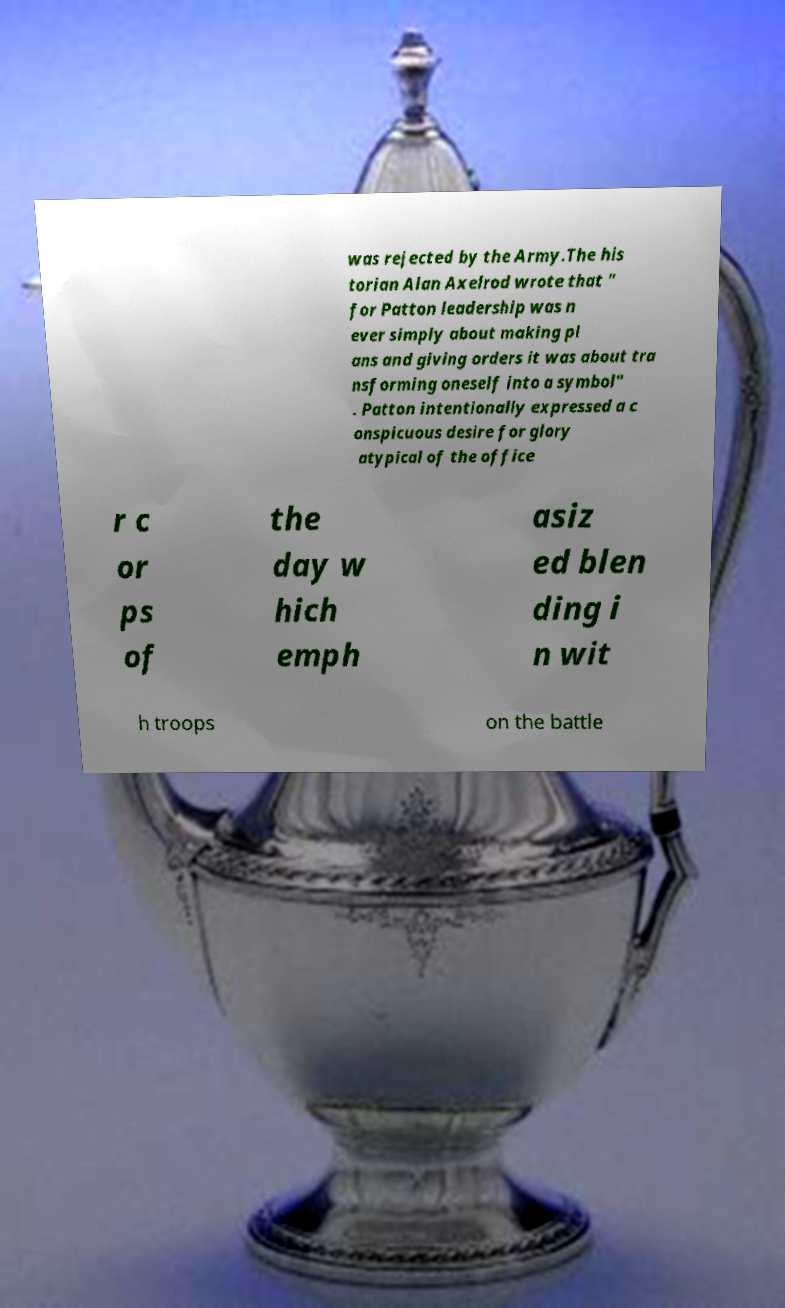What messages or text are displayed in this image? I need them in a readable, typed format. was rejected by the Army.The his torian Alan Axelrod wrote that " for Patton leadership was n ever simply about making pl ans and giving orders it was about tra nsforming oneself into a symbol" . Patton intentionally expressed a c onspicuous desire for glory atypical of the office r c or ps of the day w hich emph asiz ed blen ding i n wit h troops on the battle 